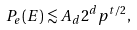Convert formula to latex. <formula><loc_0><loc_0><loc_500><loc_500>P _ { e } ( E ) \lesssim A _ { d } 2 ^ { d } p ^ { t / 2 } ,</formula> 